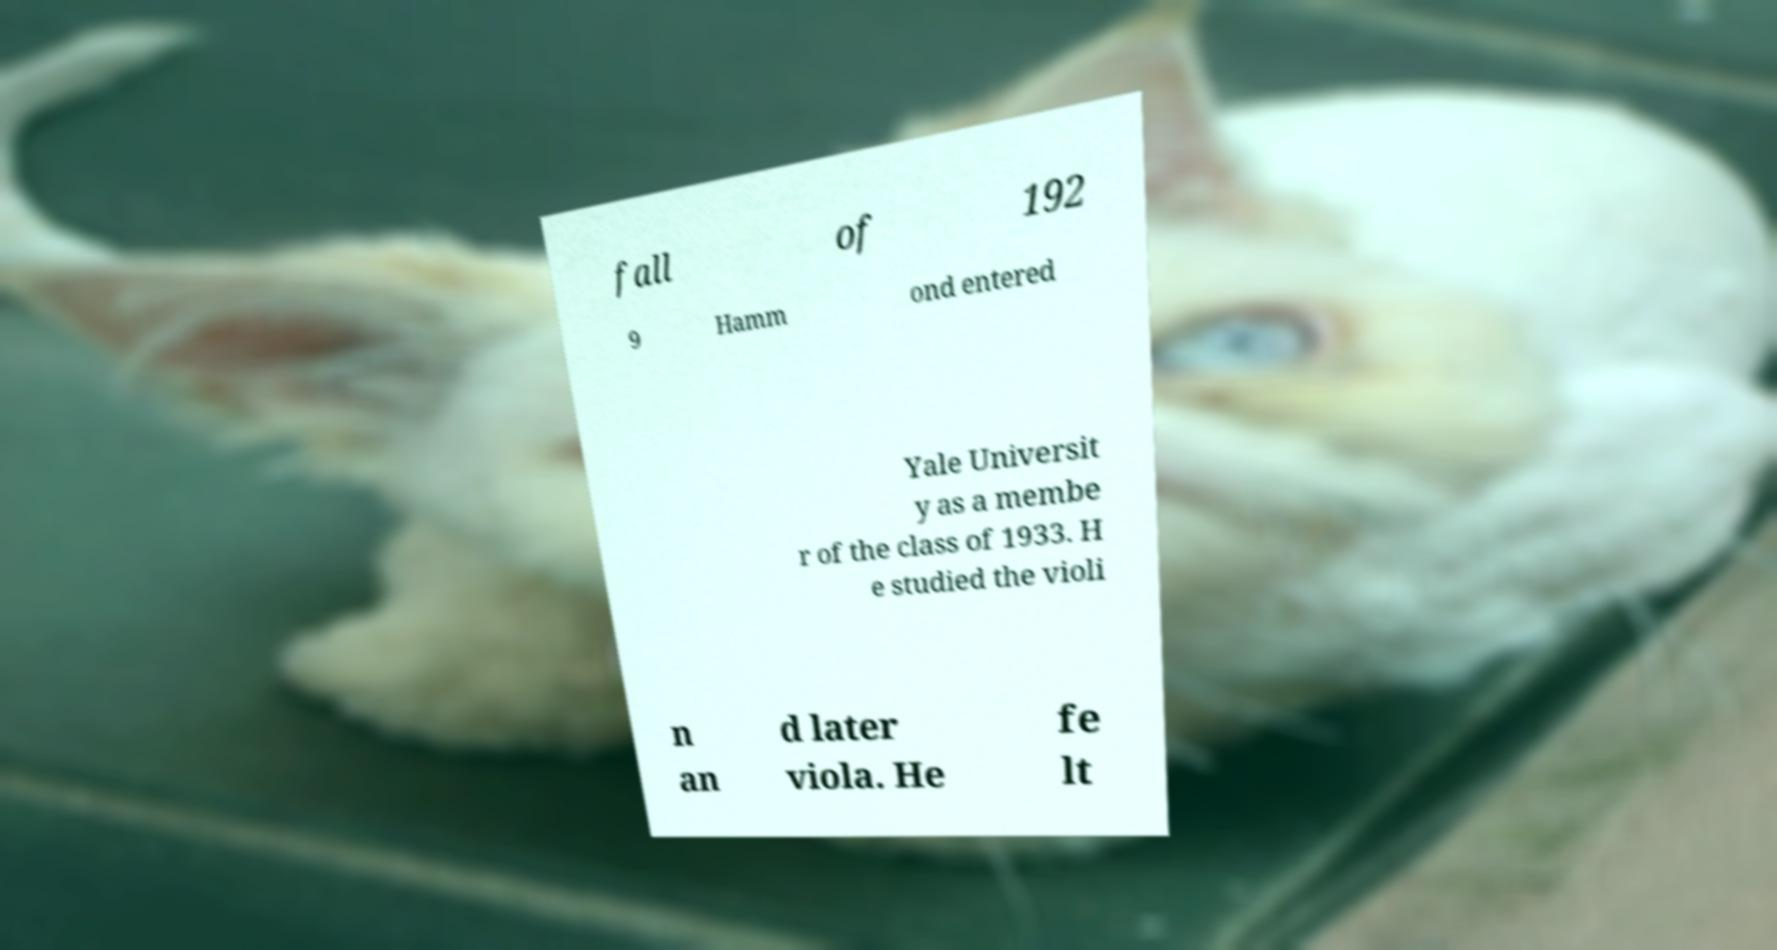Can you read and provide the text displayed in the image?This photo seems to have some interesting text. Can you extract and type it out for me? fall of 192 9 Hamm ond entered Yale Universit y as a membe r of the class of 1933. H e studied the violi n an d later viola. He fe lt 